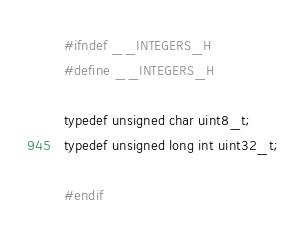Convert code to text. <code><loc_0><loc_0><loc_500><loc_500><_C_>#ifndef __INTEGERS_H
#define __INTEGERS_H

typedef unsigned char uint8_t;
typedef unsigned long int uint32_t;

#endif
</code> 